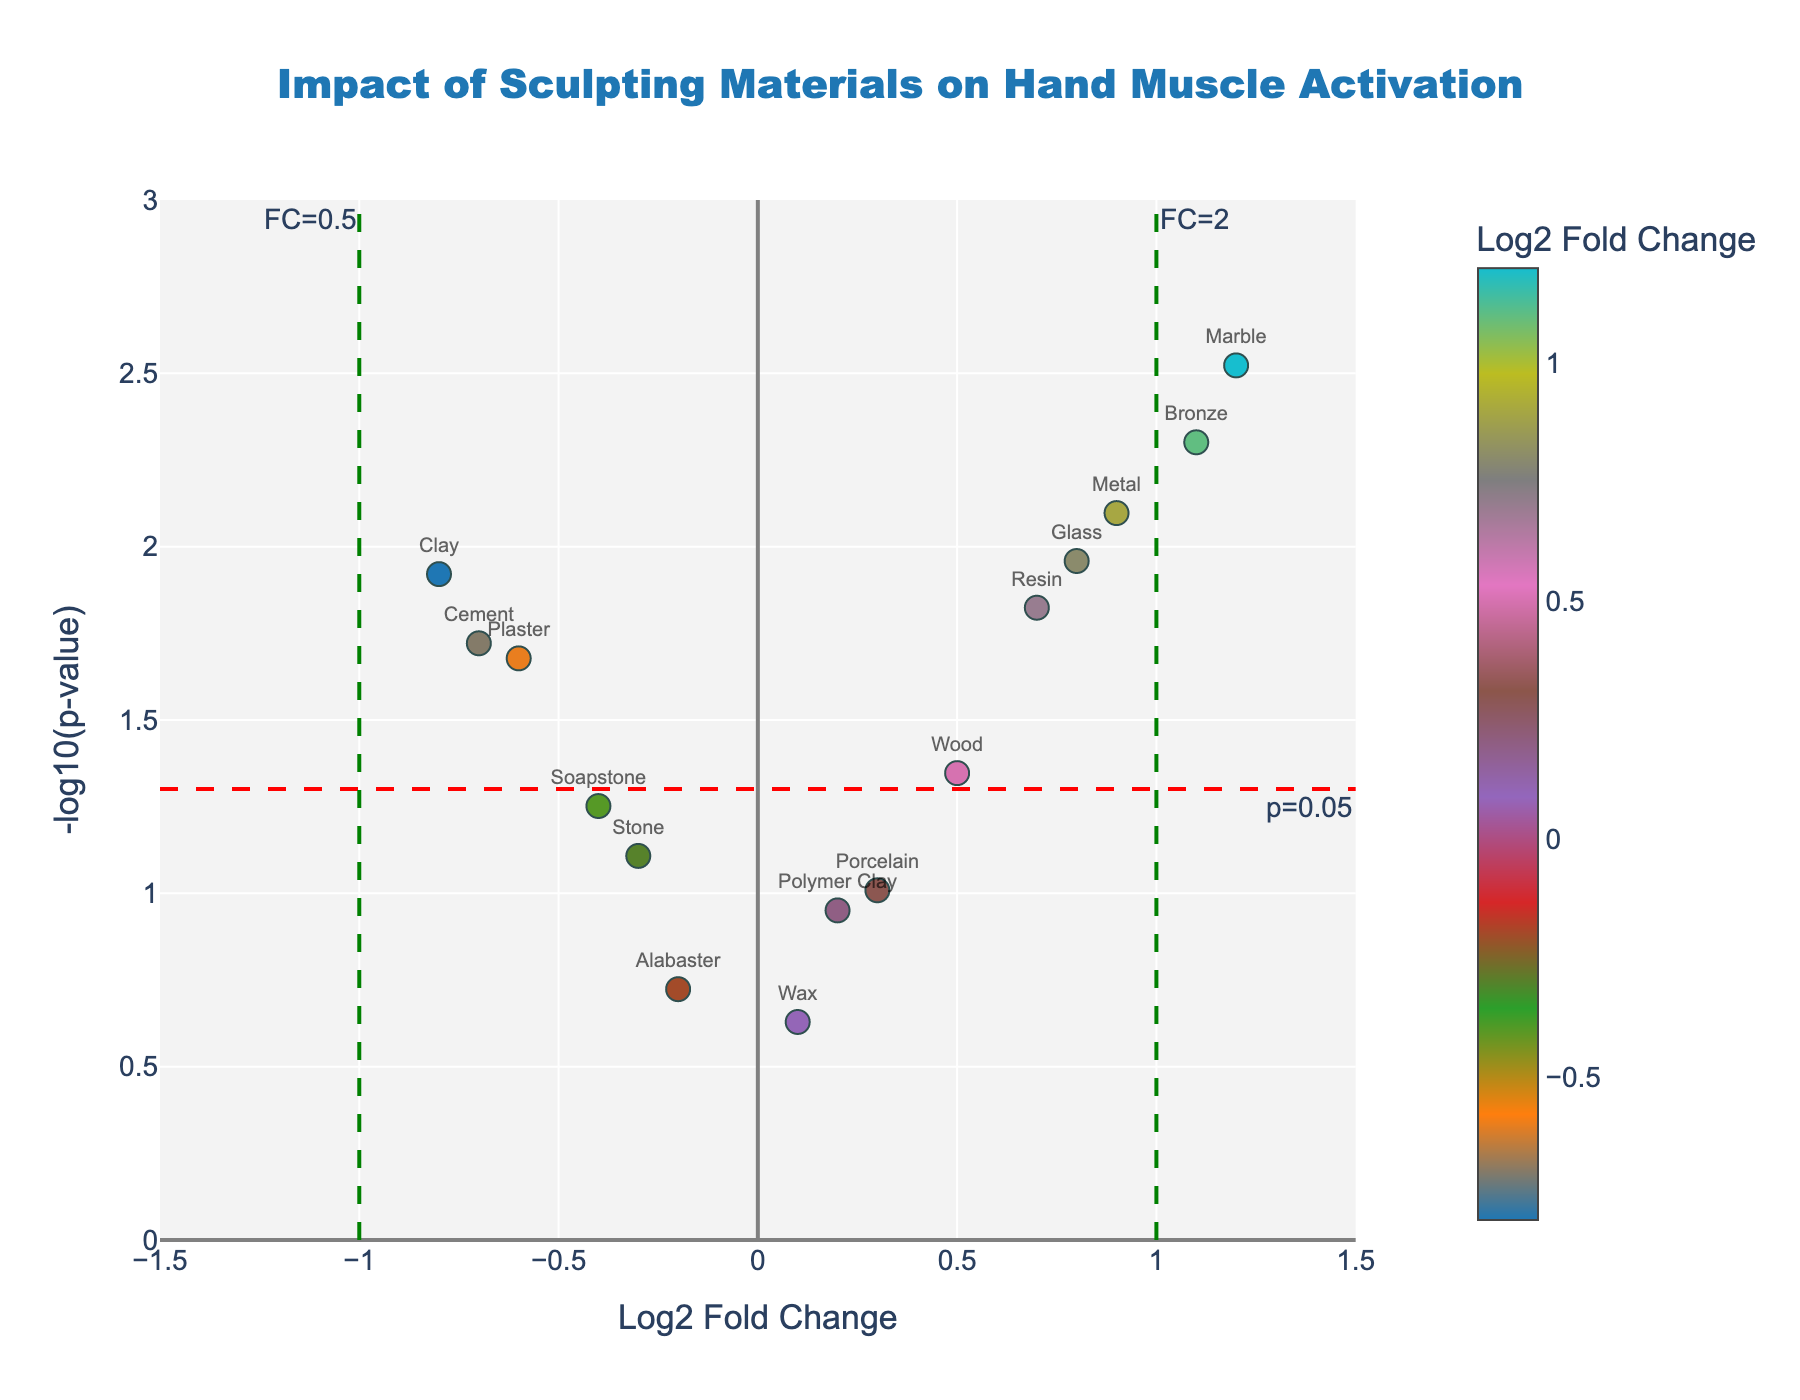What is the title of the figure? The title is located at the top center of the figure. It provides an overview of what the plot is about. The title is "Impact of Sculpting Materials on Hand Muscle Activation".
Answer: Impact of Sculpting Materials on Hand Muscle Activation How many materials have a p-value less than 0.05? From the volcano plot, we focus on the materials above the red dashed line, indicating p-values less than 0.05. Counting these points, we find there are eight such materials.
Answer: Eight Which material has the highest Log2 Fold Change? By looking at the x-axis (Log2 Fold Change), we identify the material at the farthest right on the axis. This material's label is "Marble" with a Log2 Fold Change of approximately 1.2.
Answer: Marble What colorscale is used for the markers, and what does it represent? Observing the color bar on the right of the plot, we see it represents Log2 Fold Change. The colors change from left to right, representing different values of Log2 Fold Change.
Answer: A sequential colorscale, representing Log2 Fold Change What does the red dashed line represent? The red dashed line represents the y-value where -log10(p-value) equals 1.301, which corresponds to a p-value of 0.05. This threshold line helps to identify significant effects.
Answer: p-value of 0.05 Which materials have Log2 Fold Change between -0.5 and 0.5 and a p-value less than 0.05? We look for points within the x-axis range from -0.5 to 0.5 and above the red dashed line (indicating p-value < 0.05). The materials are Clay, Wood, and Plaster.
Answer: Clay, Wood, Plaster What is the Log2 Fold Change and p-value for Metal? By finding the Metal marker on the plot and referring to the hover text or labels, we identify its values: Log2 Fold Change is approximately 0.9, and p-value is 0.008.
Answer: Log2 Fold Change: 0.9, p-value: 0.008 Which material shows the least significant impact on hand muscle activation patterns? The marker closest to the x-axis or with the smallest -log10(p-value) represents the least significant impact. Wax has the smallest -log10(p-value), indicating the least significance.
Answer: Wax What are the approximate -log10(p-value) limits of the y-axis? By observing the y-axis and its tick marks, we can see that the limits are approximately 0 to 3.
Answer: 0 to 3 Compare the Log2 Fold Change of Glass and Cement. Which is greater and by how much? Looking at the markers for Glass and Cement, the Log2 Fold Change for Glass is around 0.8, and for Cement, it is around -0.7. The difference is 0.8 - (-0.7) = 1.5.
Answer: Glass by 1.5 